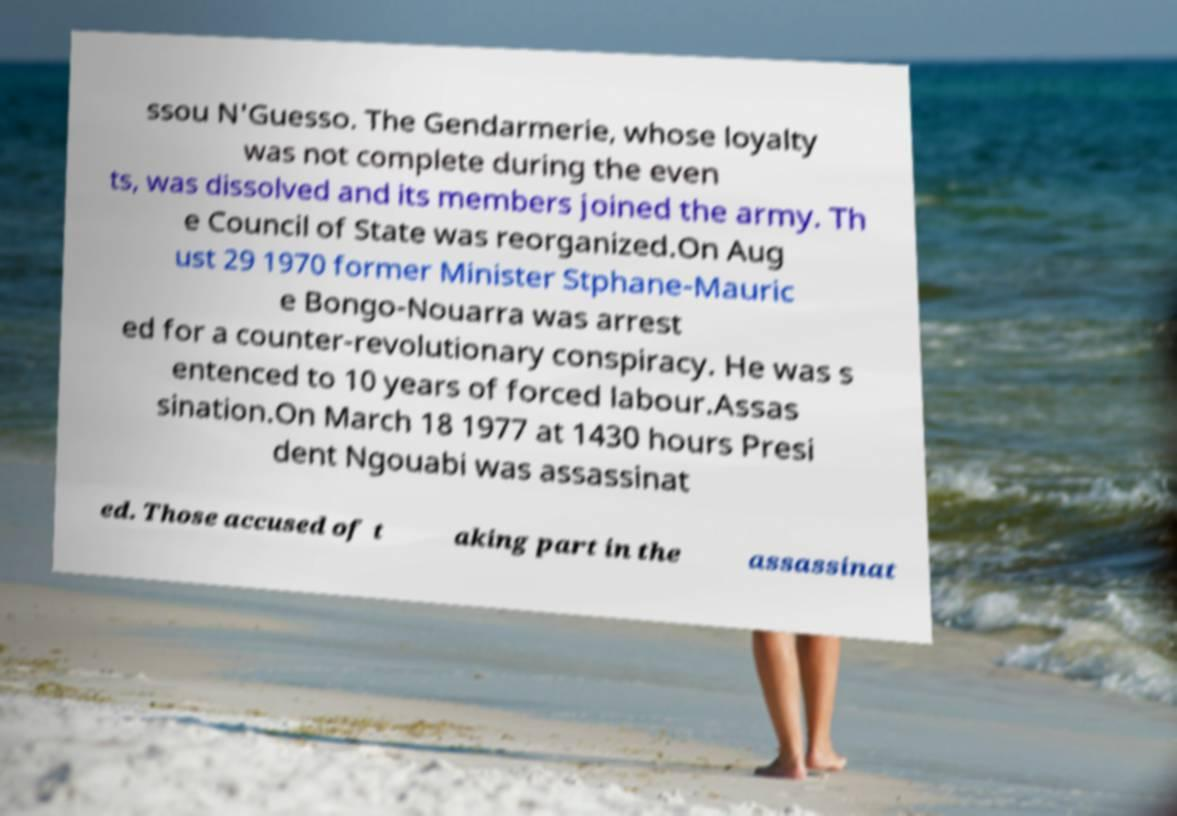Can you accurately transcribe the text from the provided image for me? ssou N'Guesso. The Gendarmerie, whose loyalty was not complete during the even ts, was dissolved and its members joined the army. Th e Council of State was reorganized.On Aug ust 29 1970 former Minister Stphane-Mauric e Bongo-Nouarra was arrest ed for a counter-revolutionary conspiracy. He was s entenced to 10 years of forced labour.Assas sination.On March 18 1977 at 1430 hours Presi dent Ngouabi was assassinat ed. Those accused of t aking part in the assassinat 